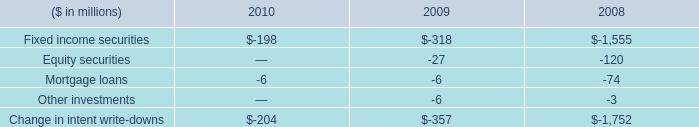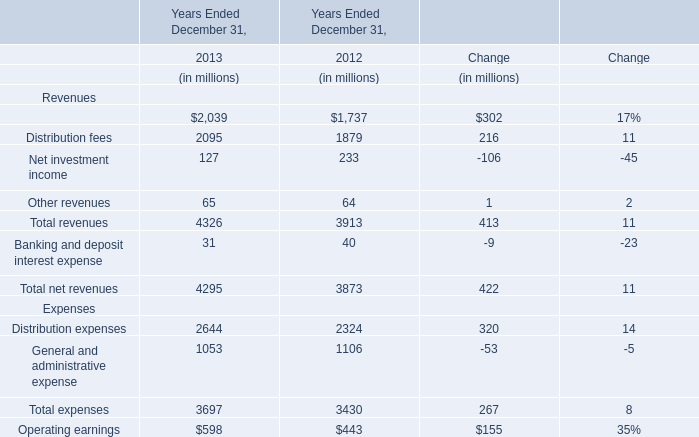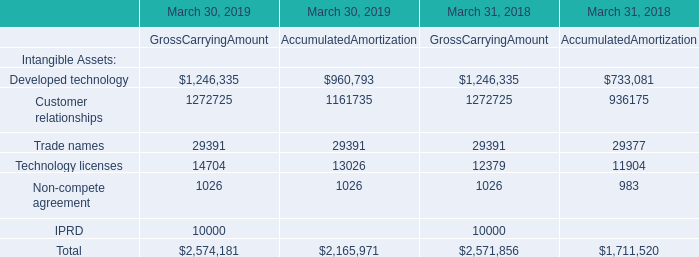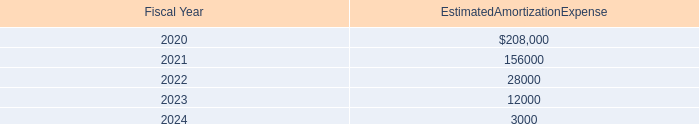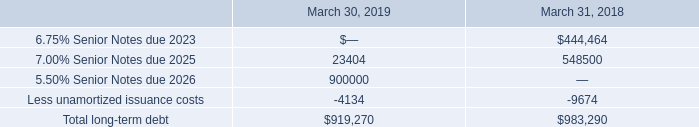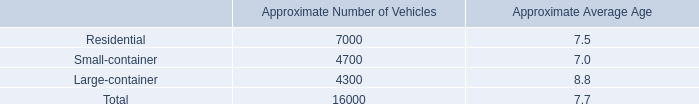as part of the total fleet what is the approximate number of vehicles converted to cng 
Computations: (16000 * 20%)
Answer: 3200.0. 